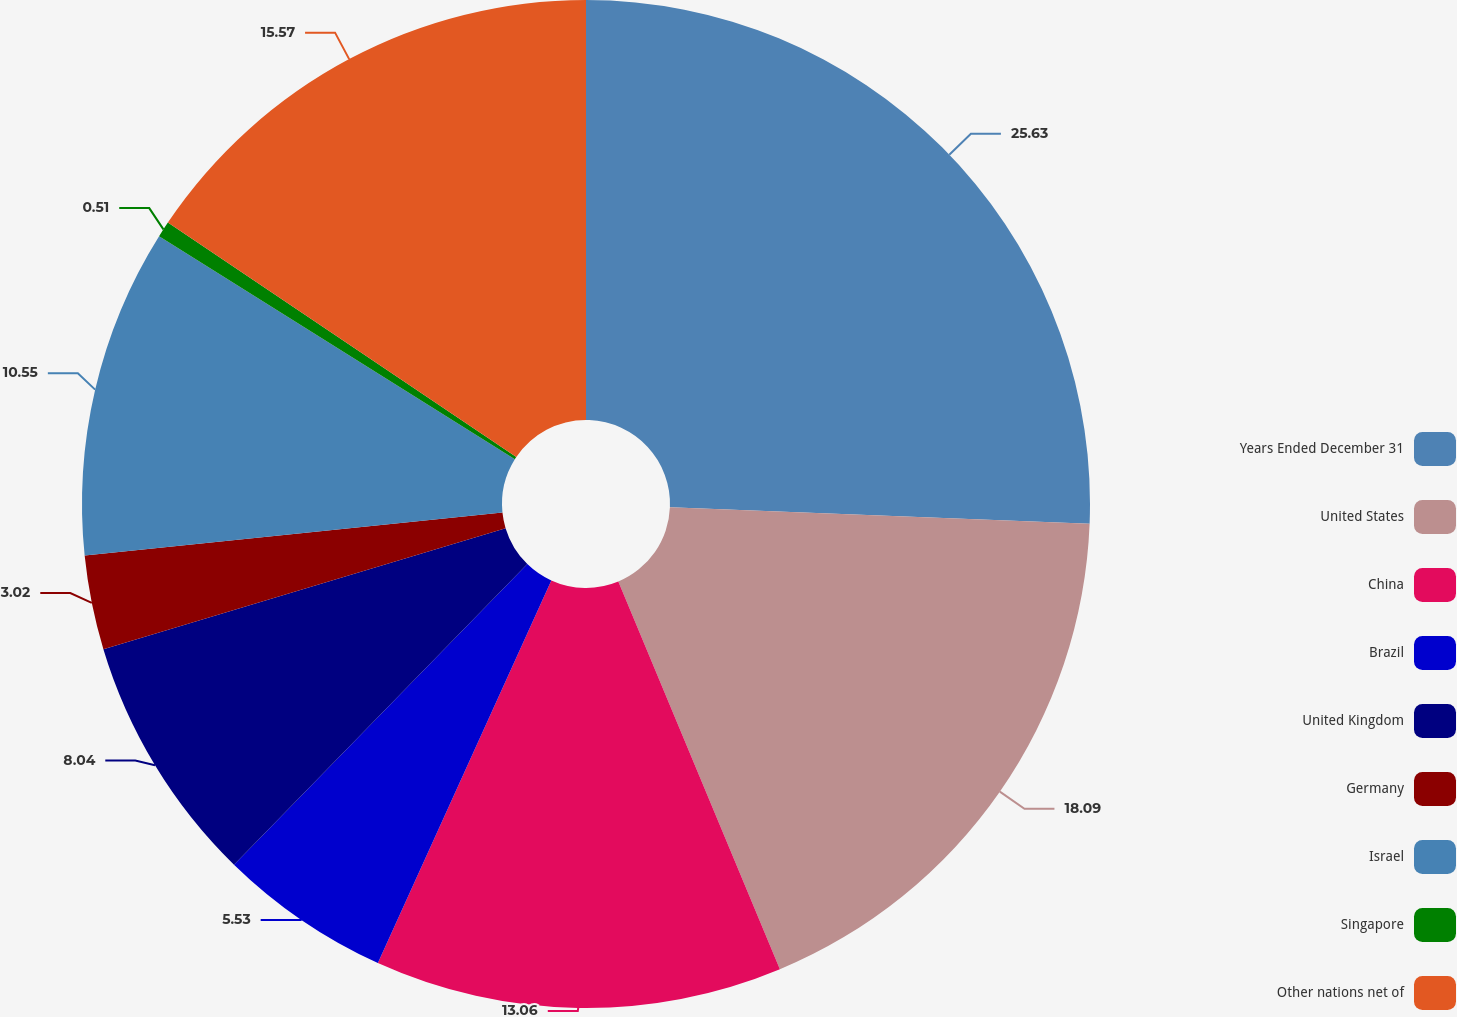Convert chart to OTSL. <chart><loc_0><loc_0><loc_500><loc_500><pie_chart><fcel>Years Ended December 31<fcel>United States<fcel>China<fcel>Brazil<fcel>United Kingdom<fcel>Germany<fcel>Israel<fcel>Singapore<fcel>Other nations net of<nl><fcel>25.62%<fcel>18.09%<fcel>13.06%<fcel>5.53%<fcel>8.04%<fcel>3.02%<fcel>10.55%<fcel>0.51%<fcel>15.57%<nl></chart> 